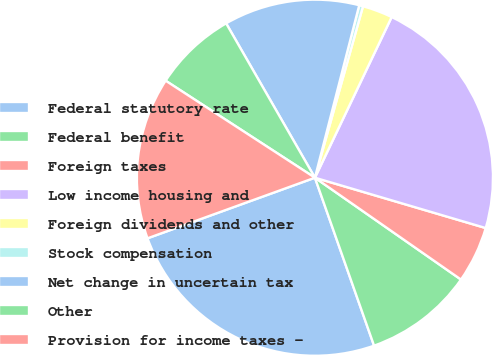Convert chart. <chart><loc_0><loc_0><loc_500><loc_500><pie_chart><fcel>Federal statutory rate<fcel>Federal benefit<fcel>Foreign taxes<fcel>Low income housing and<fcel>Foreign dividends and other<fcel>Stock compensation<fcel>Net change in uncertain tax<fcel>Other<fcel>Provision for income taxes -<nl><fcel>24.86%<fcel>9.92%<fcel>5.13%<fcel>22.47%<fcel>2.74%<fcel>0.35%<fcel>12.31%<fcel>7.52%<fcel>14.7%<nl></chart> 